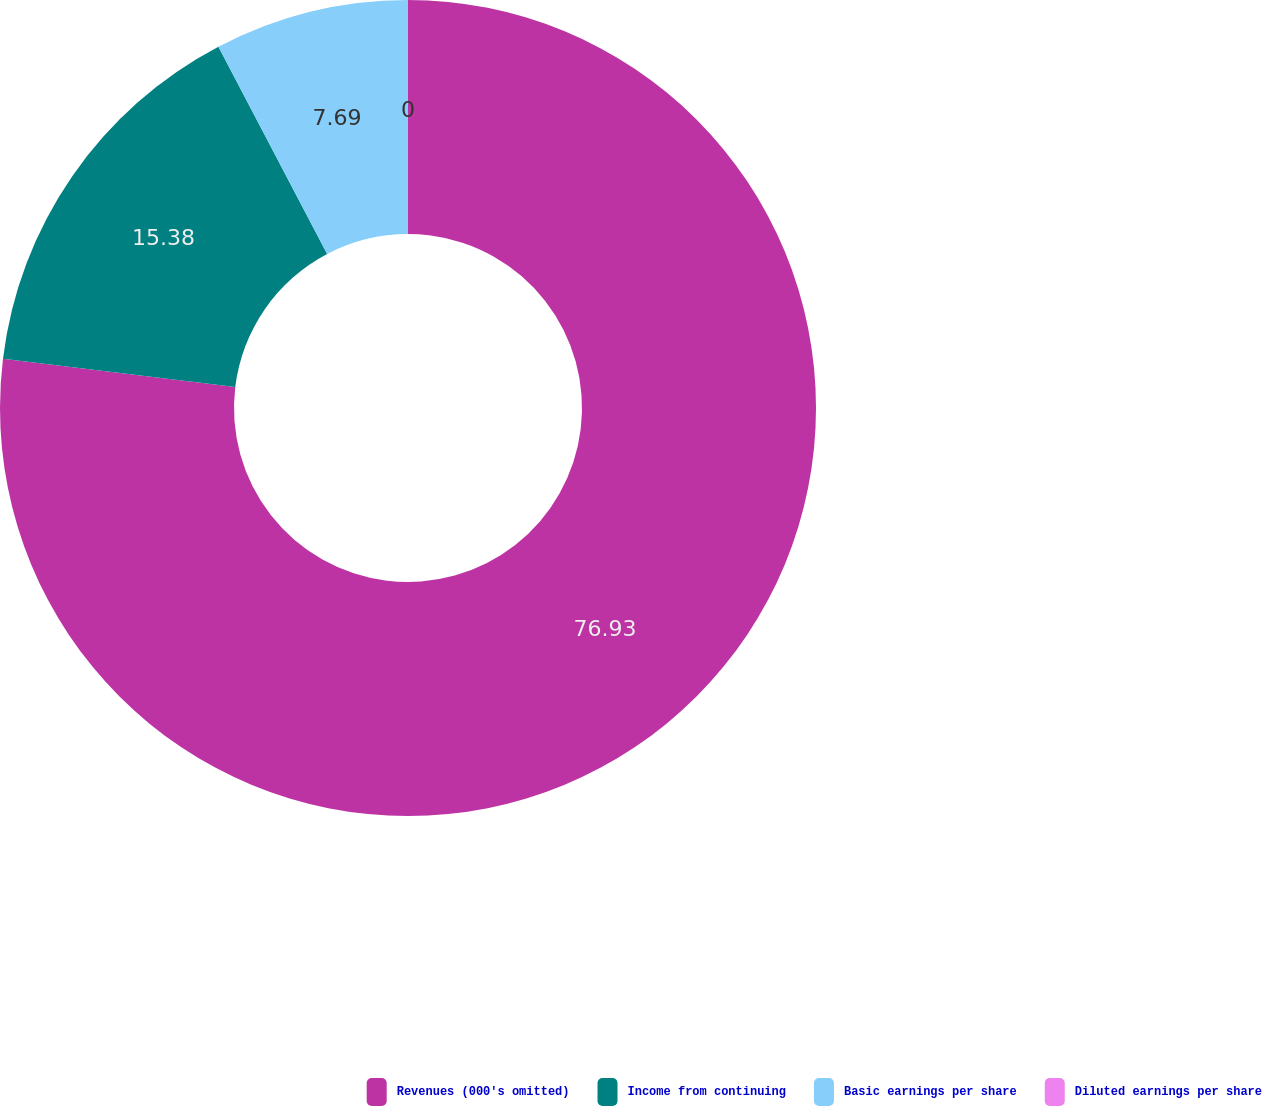<chart> <loc_0><loc_0><loc_500><loc_500><pie_chart><fcel>Revenues (000's omitted)<fcel>Income from continuing<fcel>Basic earnings per share<fcel>Diluted earnings per share<nl><fcel>76.92%<fcel>15.38%<fcel>7.69%<fcel>0.0%<nl></chart> 